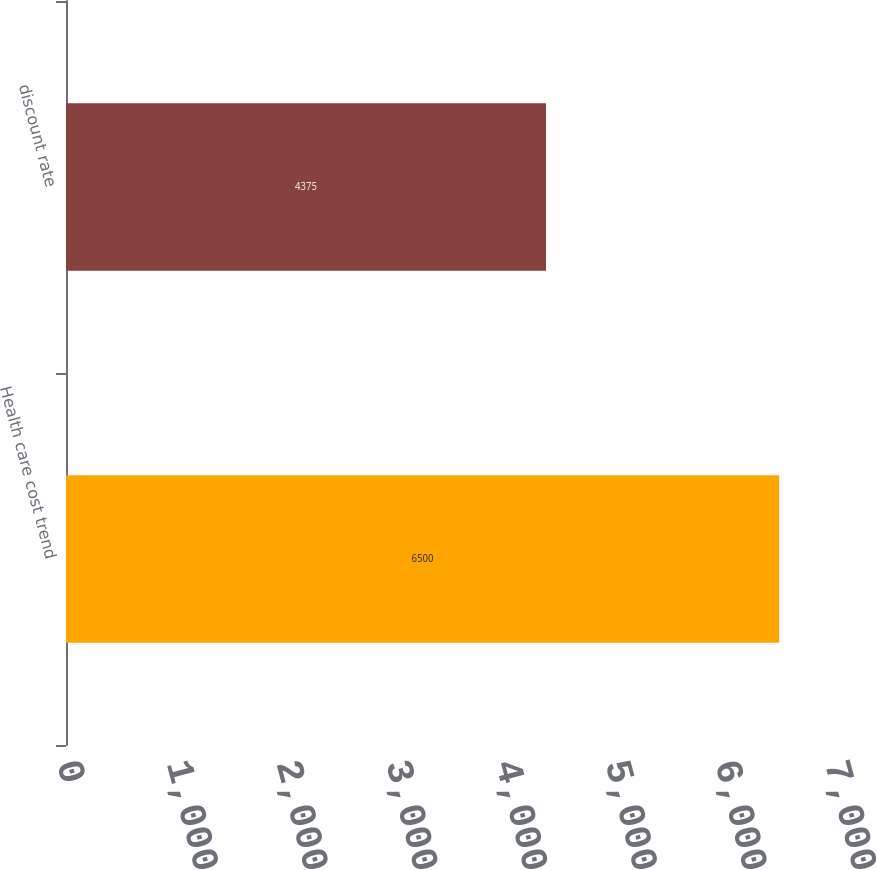<chart> <loc_0><loc_0><loc_500><loc_500><bar_chart><fcel>Health care cost trend<fcel>discount rate<nl><fcel>6500<fcel>4375<nl></chart> 